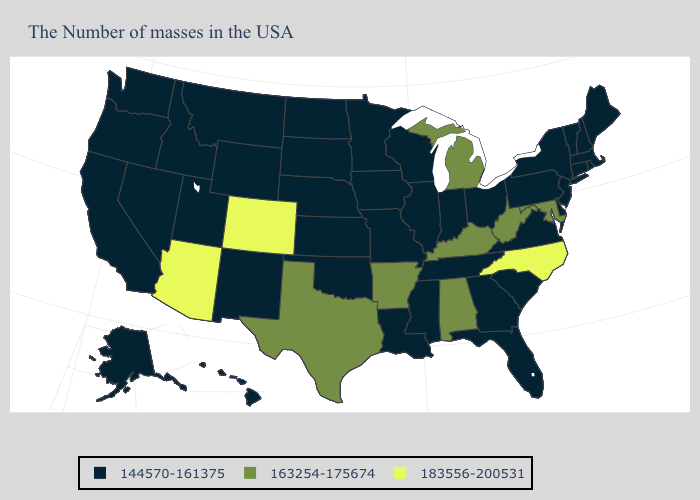What is the value of Nebraska?
Be succinct. 144570-161375. Name the states that have a value in the range 163254-175674?
Write a very short answer. Maryland, West Virginia, Michigan, Kentucky, Alabama, Arkansas, Texas. Among the states that border Florida , does Alabama have the highest value?
Answer briefly. Yes. Does the first symbol in the legend represent the smallest category?
Give a very brief answer. Yes. Does West Virginia have the same value as Alaska?
Short answer required. No. What is the value of Wisconsin?
Be succinct. 144570-161375. Does North Carolina have the highest value in the USA?
Write a very short answer. Yes. What is the highest value in the USA?
Quick response, please. 183556-200531. What is the highest value in the USA?
Write a very short answer. 183556-200531. Which states have the lowest value in the MidWest?
Be succinct. Ohio, Indiana, Wisconsin, Illinois, Missouri, Minnesota, Iowa, Kansas, Nebraska, South Dakota, North Dakota. What is the value of California?
Answer briefly. 144570-161375. Does the first symbol in the legend represent the smallest category?
Concise answer only. Yes. Name the states that have a value in the range 144570-161375?
Quick response, please. Maine, Massachusetts, Rhode Island, New Hampshire, Vermont, Connecticut, New York, New Jersey, Delaware, Pennsylvania, Virginia, South Carolina, Ohio, Florida, Georgia, Indiana, Tennessee, Wisconsin, Illinois, Mississippi, Louisiana, Missouri, Minnesota, Iowa, Kansas, Nebraska, Oklahoma, South Dakota, North Dakota, Wyoming, New Mexico, Utah, Montana, Idaho, Nevada, California, Washington, Oregon, Alaska, Hawaii. Does Oklahoma have the highest value in the South?
Give a very brief answer. No. 